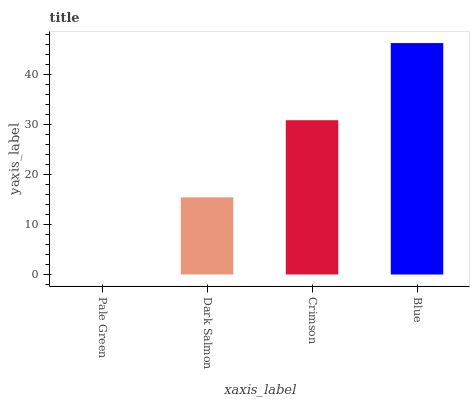Is Blue the maximum?
Answer yes or no. Yes. Is Dark Salmon the minimum?
Answer yes or no. No. Is Dark Salmon the maximum?
Answer yes or no. No. Is Dark Salmon greater than Pale Green?
Answer yes or no. Yes. Is Pale Green less than Dark Salmon?
Answer yes or no. Yes. Is Pale Green greater than Dark Salmon?
Answer yes or no. No. Is Dark Salmon less than Pale Green?
Answer yes or no. No. Is Crimson the high median?
Answer yes or no. Yes. Is Dark Salmon the low median?
Answer yes or no. Yes. Is Pale Green the high median?
Answer yes or no. No. Is Crimson the low median?
Answer yes or no. No. 